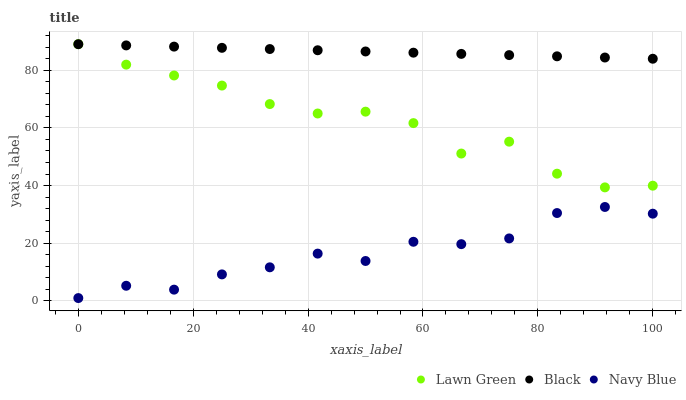Does Navy Blue have the minimum area under the curve?
Answer yes or no. Yes. Does Black have the maximum area under the curve?
Answer yes or no. Yes. Does Black have the minimum area under the curve?
Answer yes or no. No. Does Navy Blue have the maximum area under the curve?
Answer yes or no. No. Is Black the smoothest?
Answer yes or no. Yes. Is Lawn Green the roughest?
Answer yes or no. Yes. Is Navy Blue the smoothest?
Answer yes or no. No. Is Navy Blue the roughest?
Answer yes or no. No. Does Navy Blue have the lowest value?
Answer yes or no. Yes. Does Black have the lowest value?
Answer yes or no. No. Does Black have the highest value?
Answer yes or no. Yes. Does Navy Blue have the highest value?
Answer yes or no. No. Is Navy Blue less than Lawn Green?
Answer yes or no. Yes. Is Lawn Green greater than Navy Blue?
Answer yes or no. Yes. Does Lawn Green intersect Black?
Answer yes or no. Yes. Is Lawn Green less than Black?
Answer yes or no. No. Is Lawn Green greater than Black?
Answer yes or no. No. Does Navy Blue intersect Lawn Green?
Answer yes or no. No. 